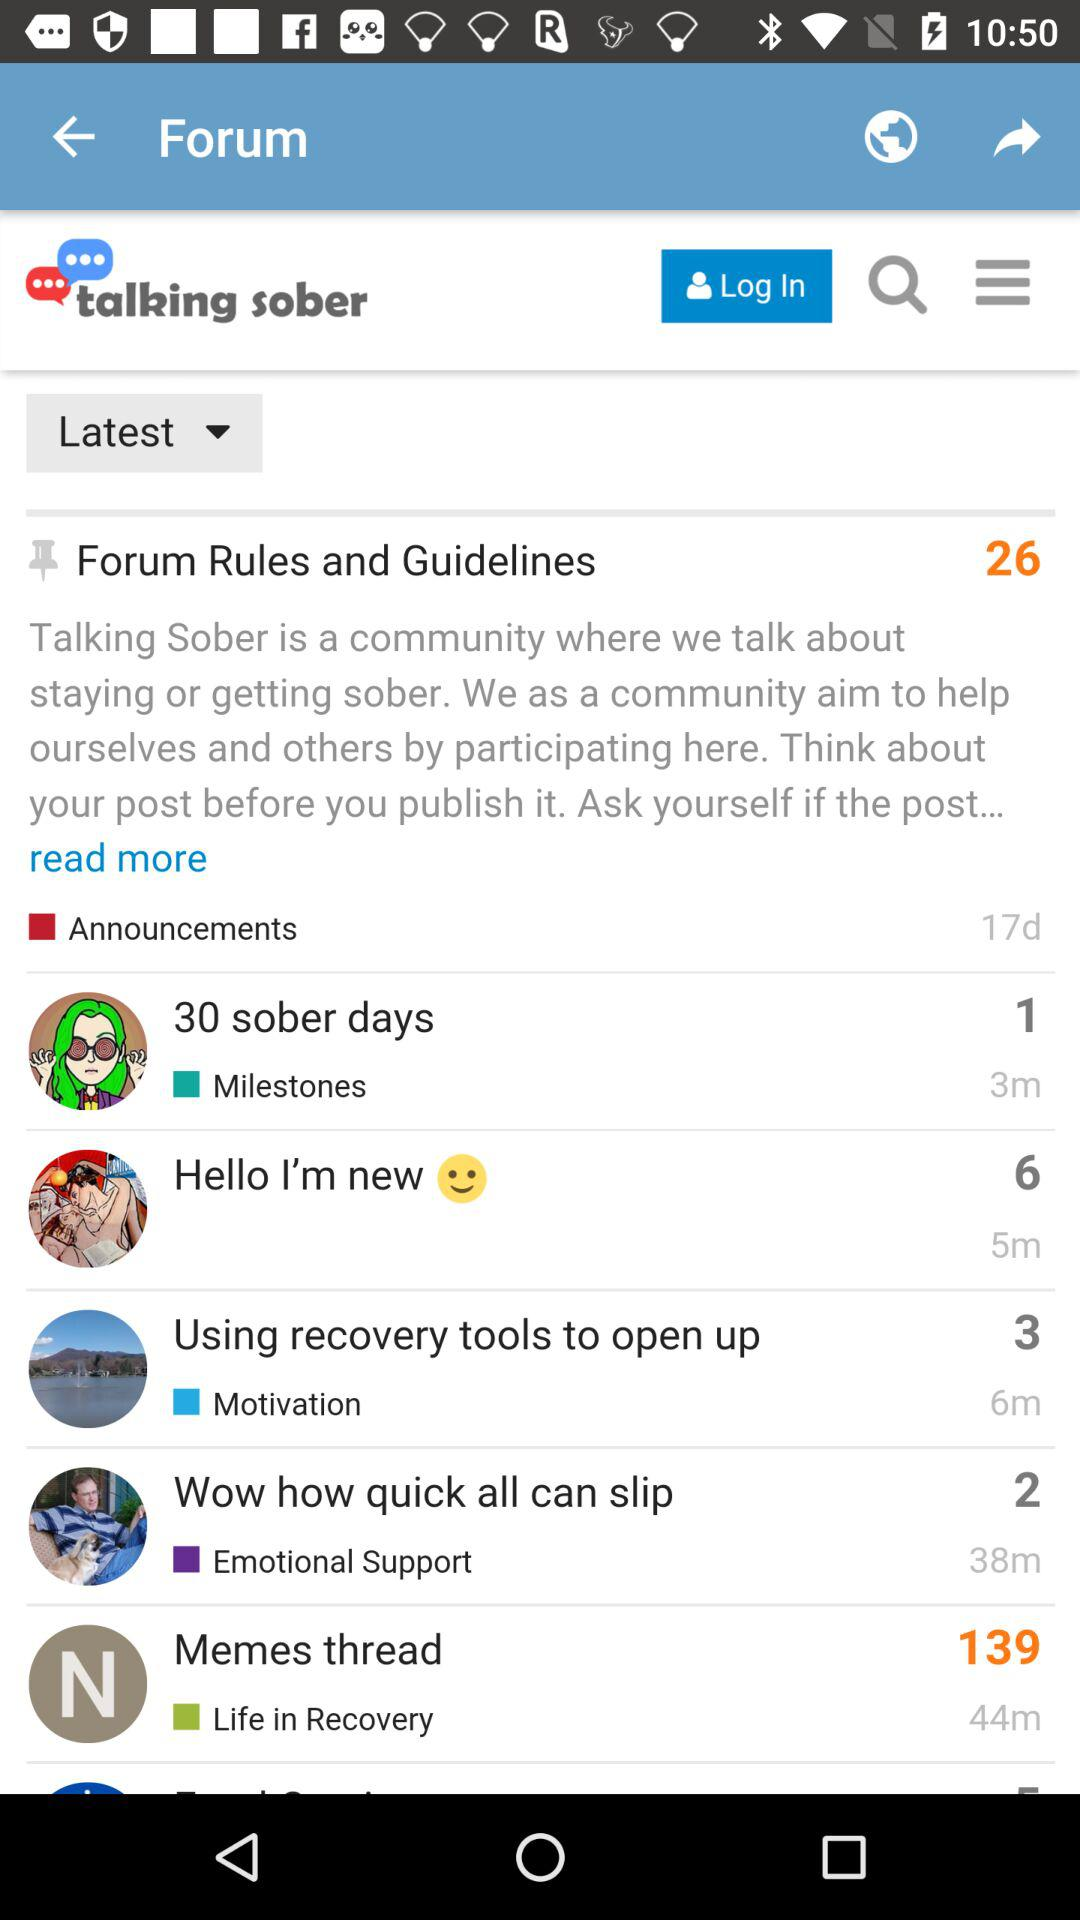What is the name of the application?
When the provided information is insufficient, respond with <no answer>. <no answer> 